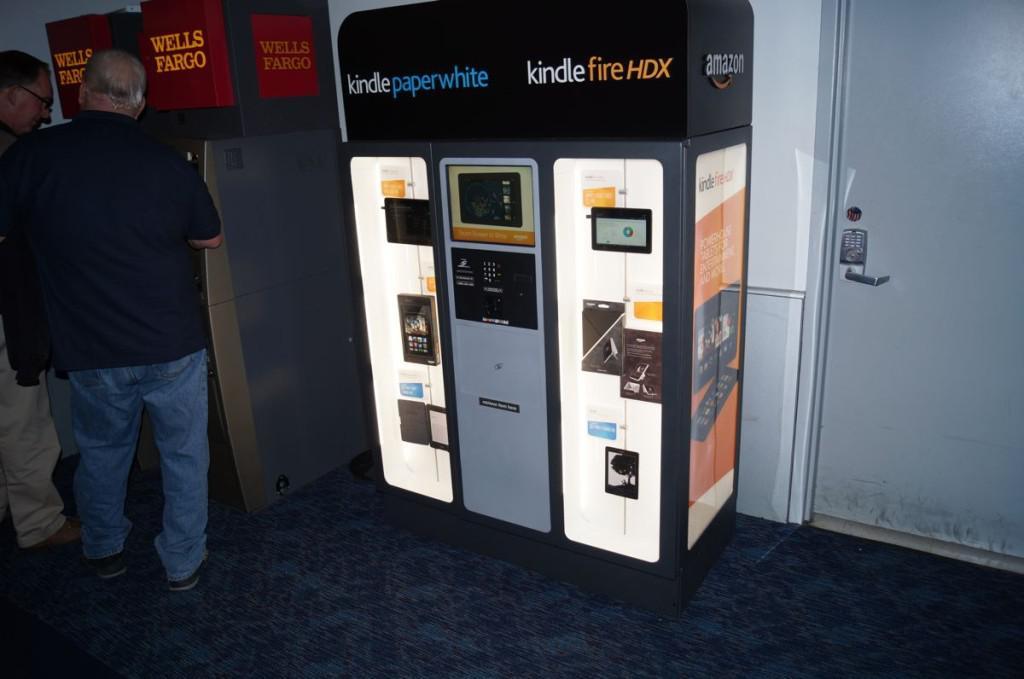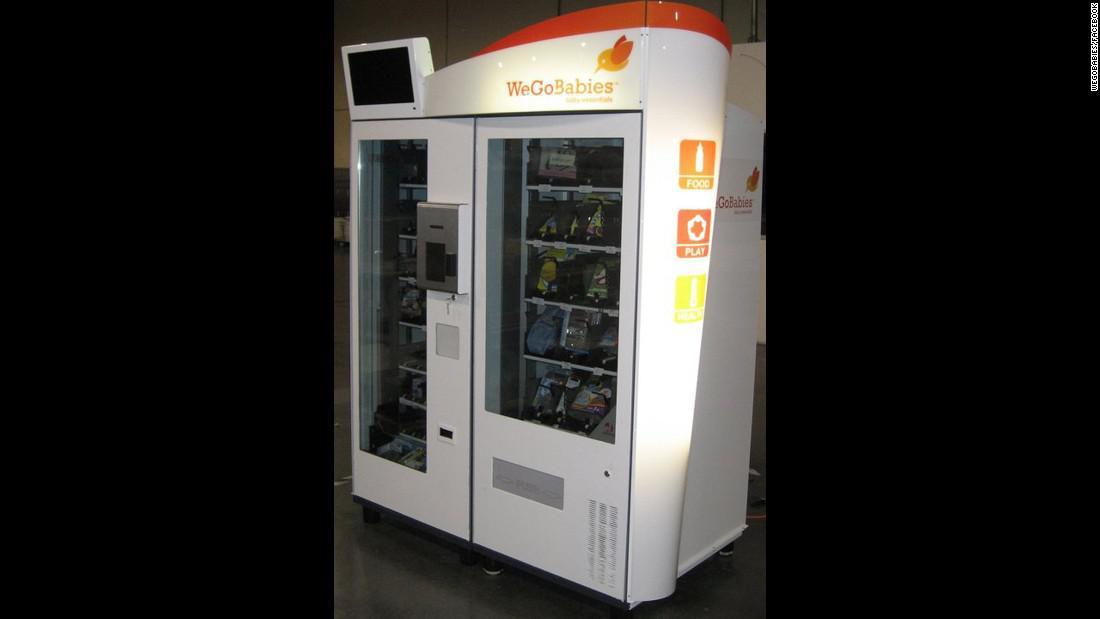The first image is the image on the left, the second image is the image on the right. Examine the images to the left and right. Is the description "Exactly two vending machines filled with snacks are shown." accurate? Answer yes or no. No. 